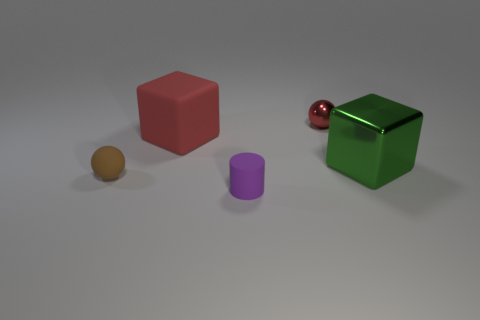Add 5 small red cubes. How many objects exist? 10 Subtract all blocks. How many objects are left? 3 Subtract all shiny blocks. Subtract all large purple metal spheres. How many objects are left? 4 Add 3 big green cubes. How many big green cubes are left? 4 Add 4 metal spheres. How many metal spheres exist? 5 Subtract 0 gray cylinders. How many objects are left? 5 